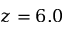<formula> <loc_0><loc_0><loc_500><loc_500>z = 6 . 0</formula> 